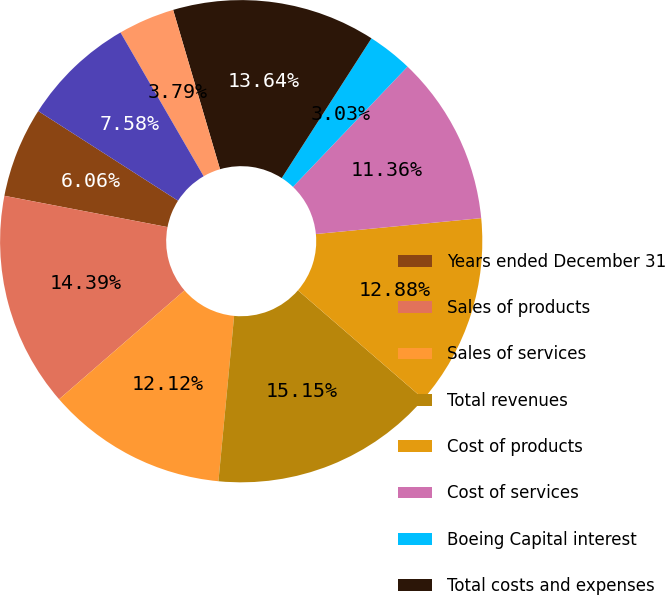Convert chart. <chart><loc_0><loc_0><loc_500><loc_500><pie_chart><fcel>Years ended December 31<fcel>Sales of products<fcel>Sales of services<fcel>Total revenues<fcel>Cost of products<fcel>Cost of services<fcel>Boeing Capital interest<fcel>Total costs and expenses<fcel>Income from operating<fcel>General and administrative<nl><fcel>6.06%<fcel>14.39%<fcel>12.12%<fcel>15.15%<fcel>12.88%<fcel>11.36%<fcel>3.03%<fcel>13.64%<fcel>3.79%<fcel>7.58%<nl></chart> 